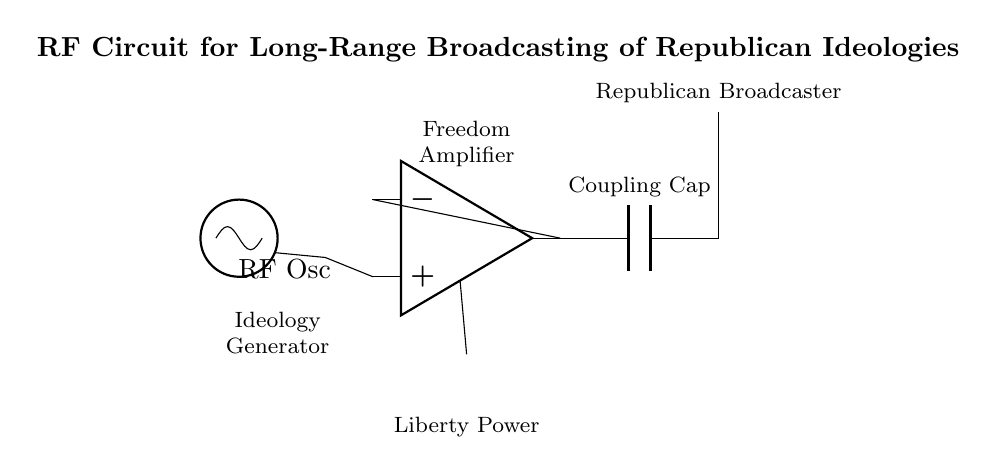What is the primary function of the RF oscillator? The RF oscillator generates the radio frequency signal needed to broadcast the republican ideologies. This component is essential as it sets the communication frequency of the circuit.
Answer: RF oscillator What type of component is the amplifier? The amplifier is an operational amplifier, which amplifies the signal from the RF oscillator to a level suitable for transmission. It boosts the strength of the ideologies being broadcasted for long-range reach.
Answer: Operational amplifier How is the power supplied to the amplifier? The power to the amplifier is supplied by a battery, which provides the necessary voltage for the operational amplifier to function correctly and amplify the signal.
Answer: Battery What does the coupling capacitor do in this circuit? The coupling capacitor allows the RF signal to pass from the amplifier to the antenna while blocking any DC components, ensuring only the alternating current signal is transmitted.
Answer: Pass RF signal What is the purpose of the antenna in this circuit? The antenna serves to radiate the amplified RF signal into the air for broadcasting the republican ideologies over long distances. It converts the electrical signals into electromagnetic waves.
Answer: Radiate signal What is the label associated with the amplifier in the diagram? The amplifier is labeled as "Freedom Amplifier," indicating its role in amplifying the ideology transmission signal. This suggests the circuit promotes the concept of freedom through its output.
Answer: Freedom Amplifier What does the label "Ideology Generator" refer to? The label "Ideology Generator" refers to the RF oscillator, which produces the base frequency signal that represents the republican ideologies intended for transmission.
Answer: RF oscillator 